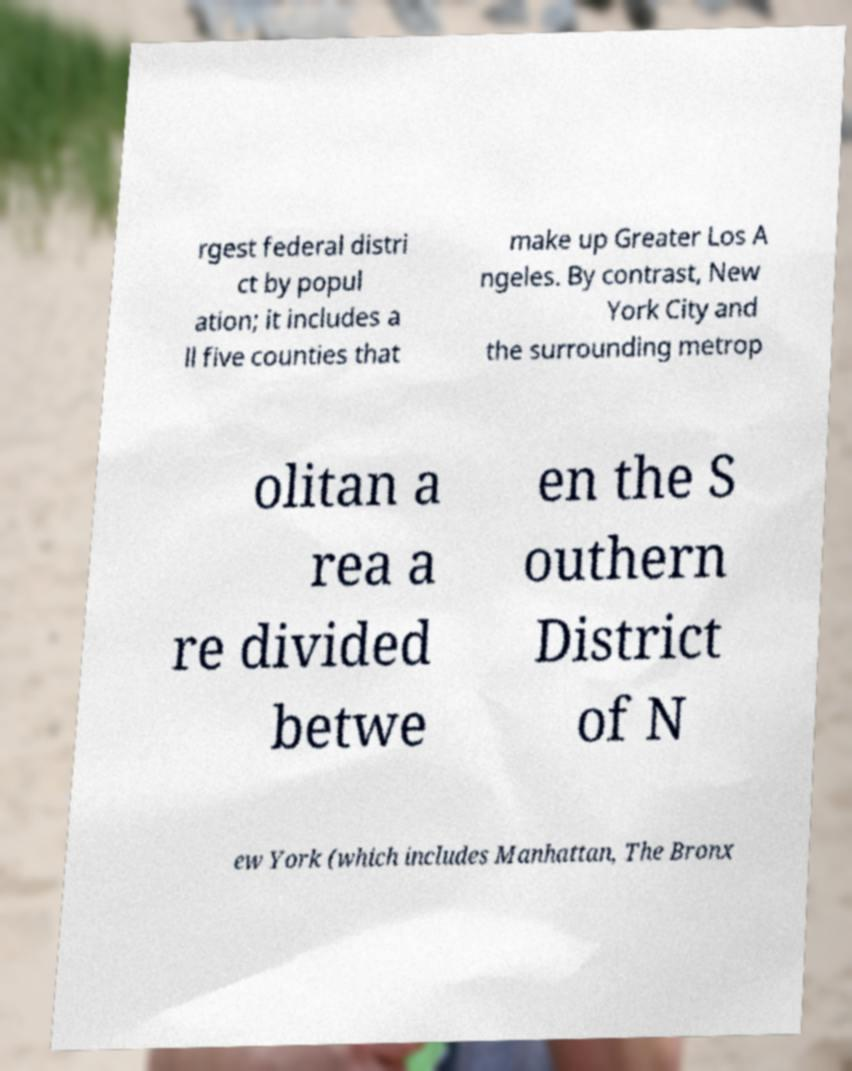Can you accurately transcribe the text from the provided image for me? rgest federal distri ct by popul ation; it includes a ll five counties that make up Greater Los A ngeles. By contrast, New York City and the surrounding metrop olitan a rea a re divided betwe en the S outhern District of N ew York (which includes Manhattan, The Bronx 